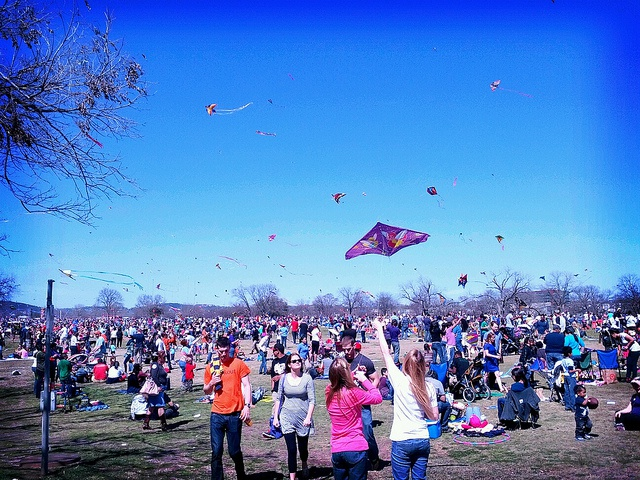Describe the objects in this image and their specific colors. I can see people in blue, black, gray, navy, and lavender tones, people in blue, white, black, brown, and darkgray tones, people in blue, violet, black, magenta, and purple tones, people in blue, black, salmon, navy, and lavender tones, and people in blue, lavender, black, darkgray, and gray tones in this image. 